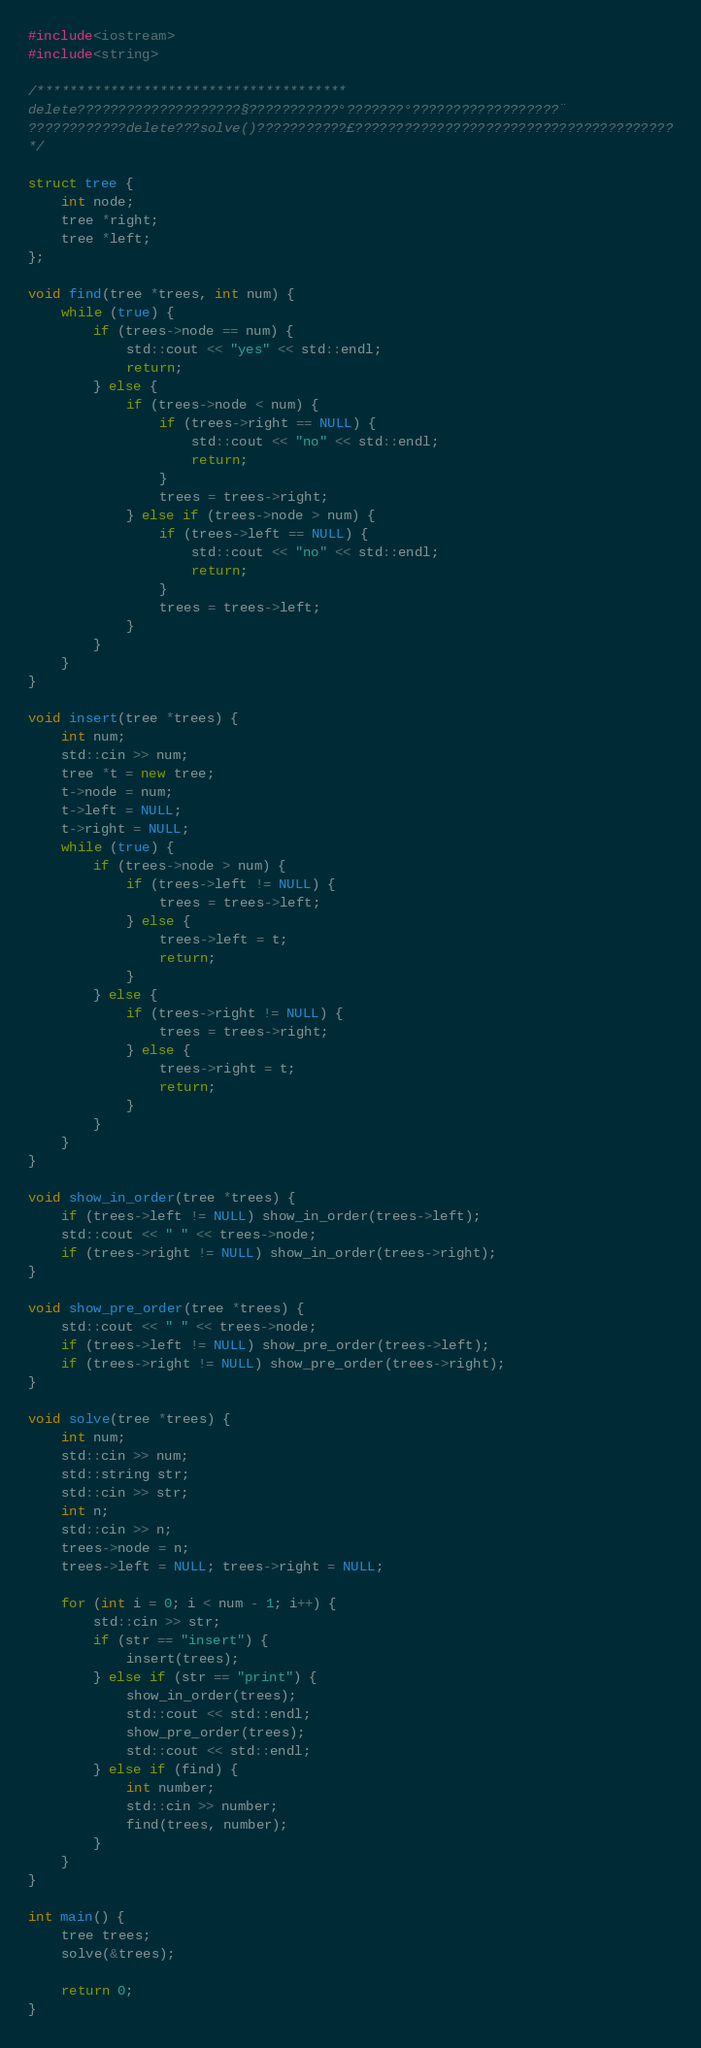Convert code to text. <code><loc_0><loc_0><loc_500><loc_500><_C++_>#include<iostream>
#include<string>

/**************************************
delete????????????????????§???????????°???????°??????????????????¨
????????????delete???solve()???????????£???????????????????????????????????????
*/

struct tree {
	int node;
	tree *right;
	tree *left;
};

void find(tree *trees, int num) {
	while (true) {
		if (trees->node == num) {
			std::cout << "yes" << std::endl;
			return;
		} else {
			if (trees->node < num) {
				if (trees->right == NULL) {
					std::cout << "no" << std::endl;
					return;
				}
				trees = trees->right;
			} else if (trees->node > num) {
				if (trees->left == NULL) {
					std::cout << "no" << std::endl;
					return;
				}
				trees = trees->left;
			}
		}
	}
}

void insert(tree *trees) {
	int num;
	std::cin >> num;
	tree *t = new tree;
	t->node = num;
	t->left = NULL;
	t->right = NULL;
	while (true) {
		if (trees->node > num) {
			if (trees->left != NULL) {
				trees = trees->left;
			} else {
				trees->left = t;
				return;
			}
		} else {
			if (trees->right != NULL) {
				trees = trees->right;
			} else {
				trees->right = t;
				return;
			}
		}
	}
}

void show_in_order(tree *trees) {
	if (trees->left != NULL) show_in_order(trees->left);
	std::cout << " " << trees->node;
	if (trees->right != NULL) show_in_order(trees->right);
}

void show_pre_order(tree *trees) {
	std::cout << " " << trees->node;
	if (trees->left != NULL) show_pre_order(trees->left);
	if (trees->right != NULL) show_pre_order(trees->right);
}

void solve(tree *trees) {
	int num;
	std::cin >> num;
	std::string str;
	std::cin >> str;
	int n;
	std::cin >> n;
	trees->node = n;
	trees->left = NULL; trees->right = NULL;

	for (int i = 0; i < num - 1; i++) {
		std::cin >> str;
		if (str == "insert") {
			insert(trees);
		} else if (str == "print") {
			show_in_order(trees);
			std::cout << std::endl;
			show_pre_order(trees);
			std::cout << std::endl;
		} else if (find) {
			int number;
			std::cin >> number;
			find(trees, number);
		}
	}
}

int main() {
	tree trees;
	solve(&trees);

	return 0;
}</code> 